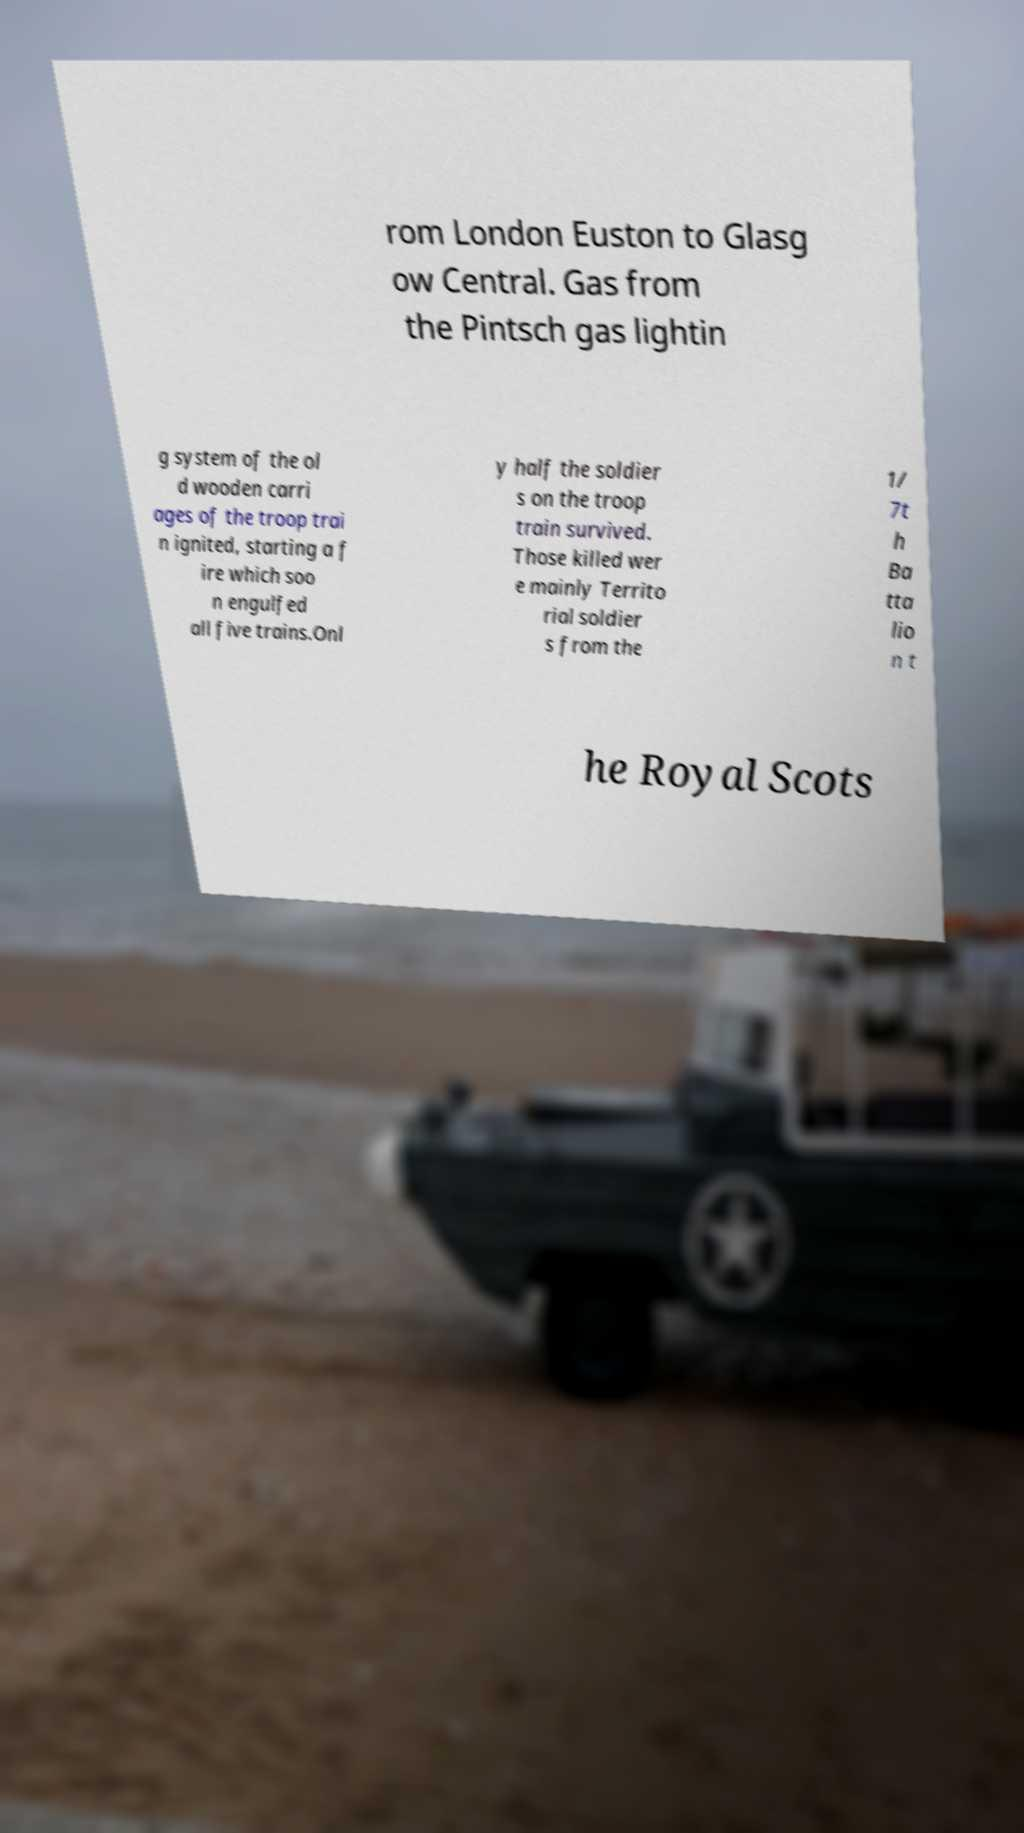Please identify and transcribe the text found in this image. rom London Euston to Glasg ow Central. Gas from the Pintsch gas lightin g system of the ol d wooden carri ages of the troop trai n ignited, starting a f ire which soo n engulfed all five trains.Onl y half the soldier s on the troop train survived. Those killed wer e mainly Territo rial soldier s from the 1/ 7t h Ba tta lio n t he Royal Scots 